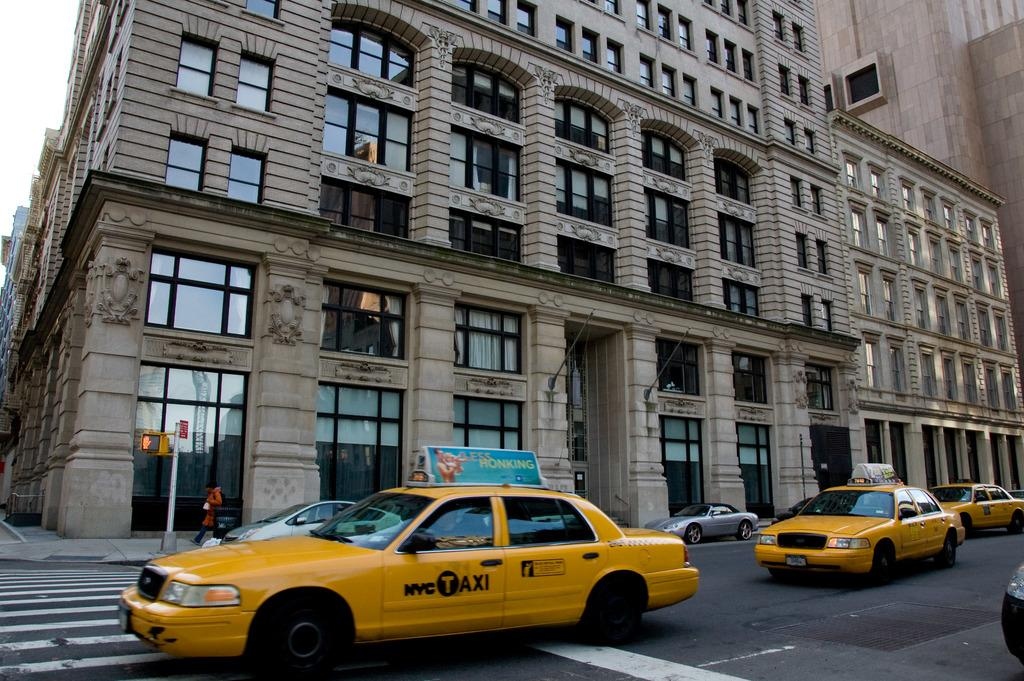<image>
Give a short and clear explanation of the subsequent image. A NYC Taxi has a sign on the top of the vehicle that says less honking. 